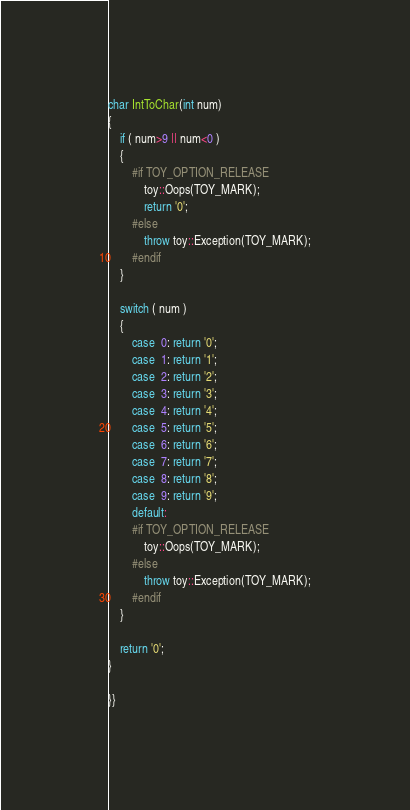Convert code to text. <code><loc_0><loc_0><loc_500><loc_500><_C++_>
char IntToChar(int num)
{
	if ( num>9 || num<0 )
	{
		#if TOY_OPTION_RELEASE
			toy::Oops(TOY_MARK);
			return '0';
		#else
			throw toy::Exception(TOY_MARK);
		#endif
	}

	switch ( num )
	{
		case  0: return '0';
		case  1: return '1';
		case  2: return '2';
		case  3: return '3';
		case  4: return '4';
		case  5: return '5';
		case  6: return '6';
		case  7: return '7';
		case  8: return '8';
		case  9: return '9';
		default:
		#if TOY_OPTION_RELEASE
			toy::Oops(TOY_MARK);
		#else
			throw toy::Exception(TOY_MARK);
		#endif
	}

	return '0';
}

}}
</code> 